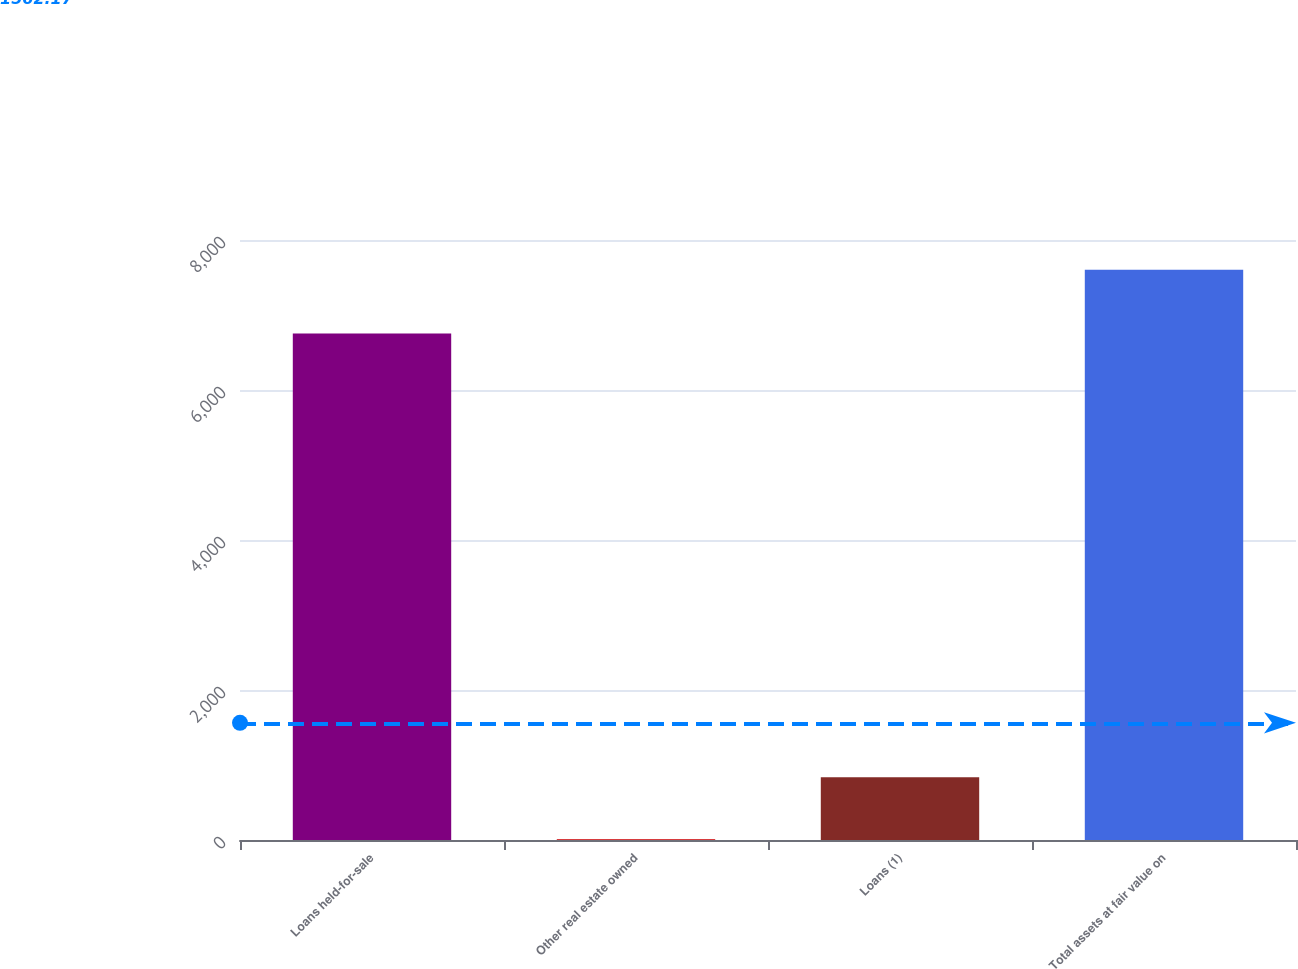Convert chart to OTSL. <chart><loc_0><loc_0><loc_500><loc_500><bar_chart><fcel>Loans held-for-sale<fcel>Other real estate owned<fcel>Loans (1)<fcel>Total assets at fair value on<nl><fcel>6752<fcel>15<fcel>836<fcel>7603<nl></chart> 